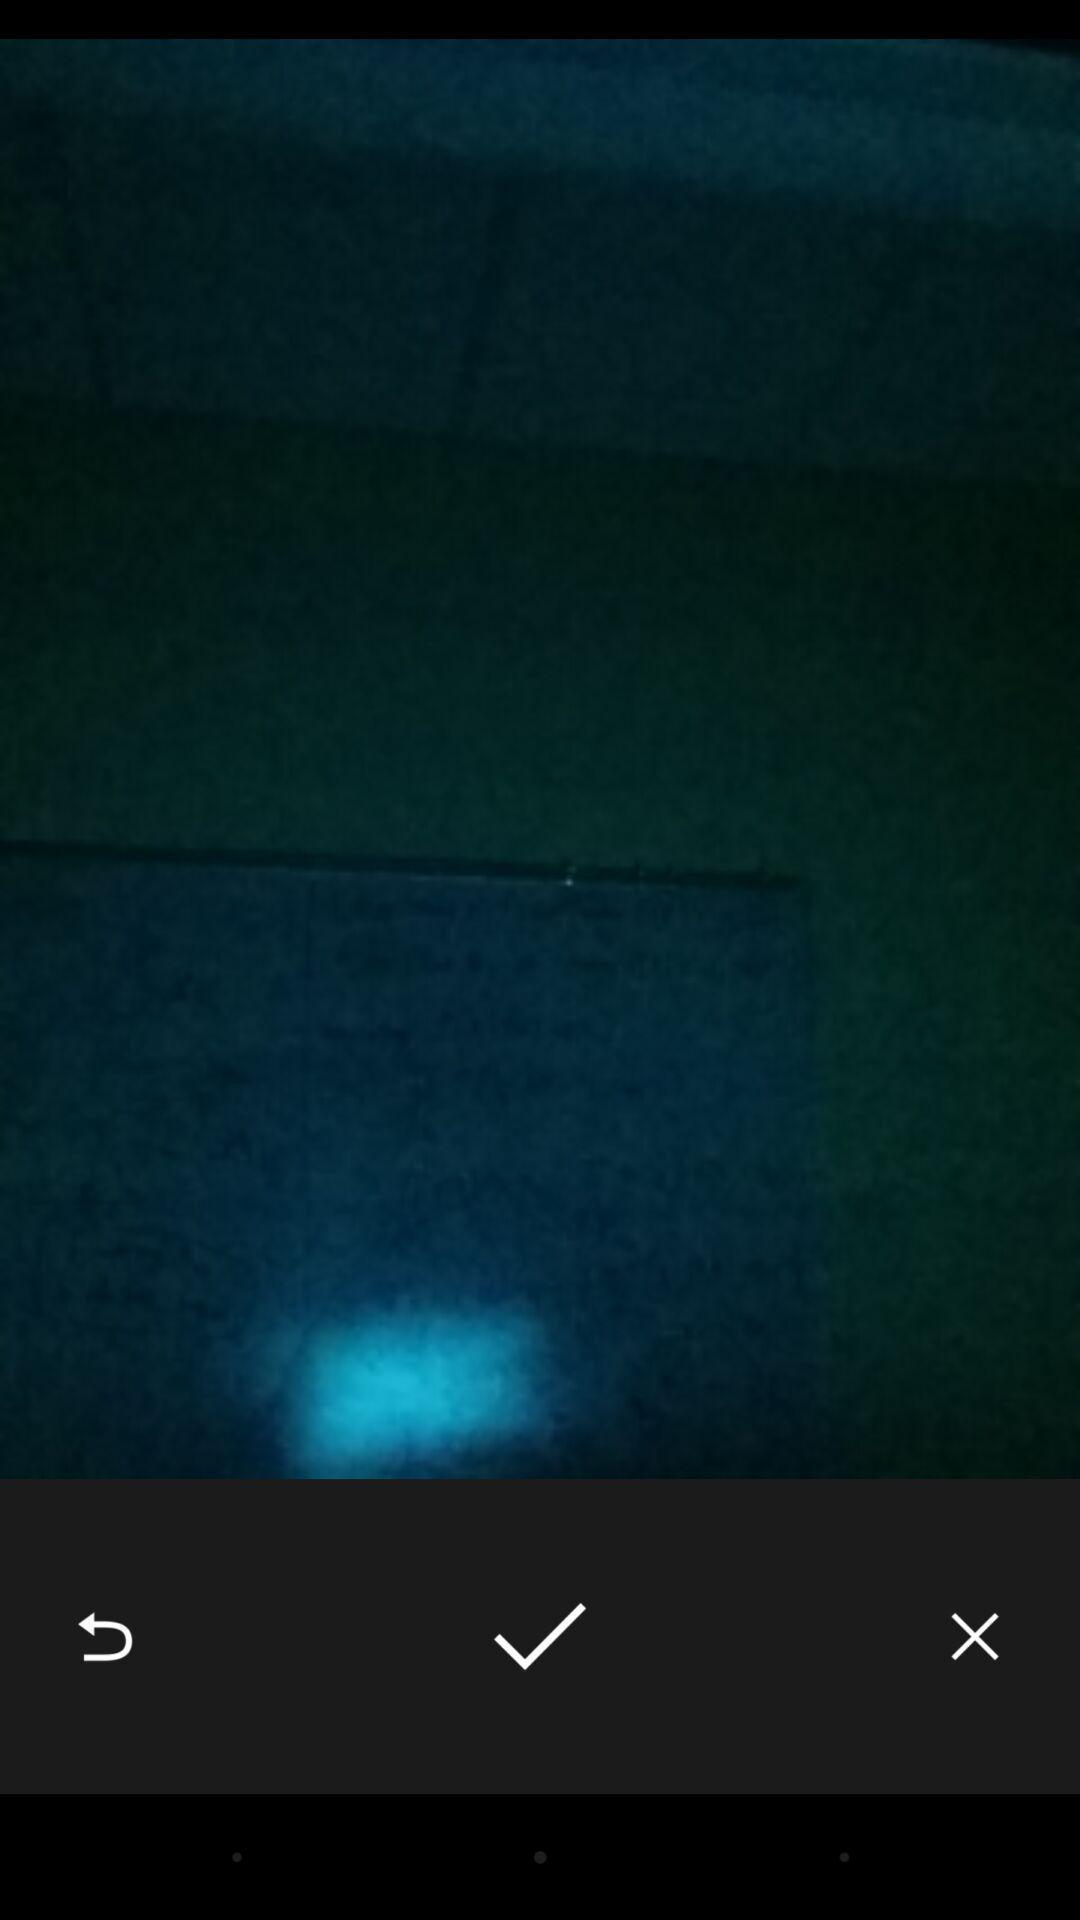Provide a textual representation of this image. Screen shows blank page with tick option. 